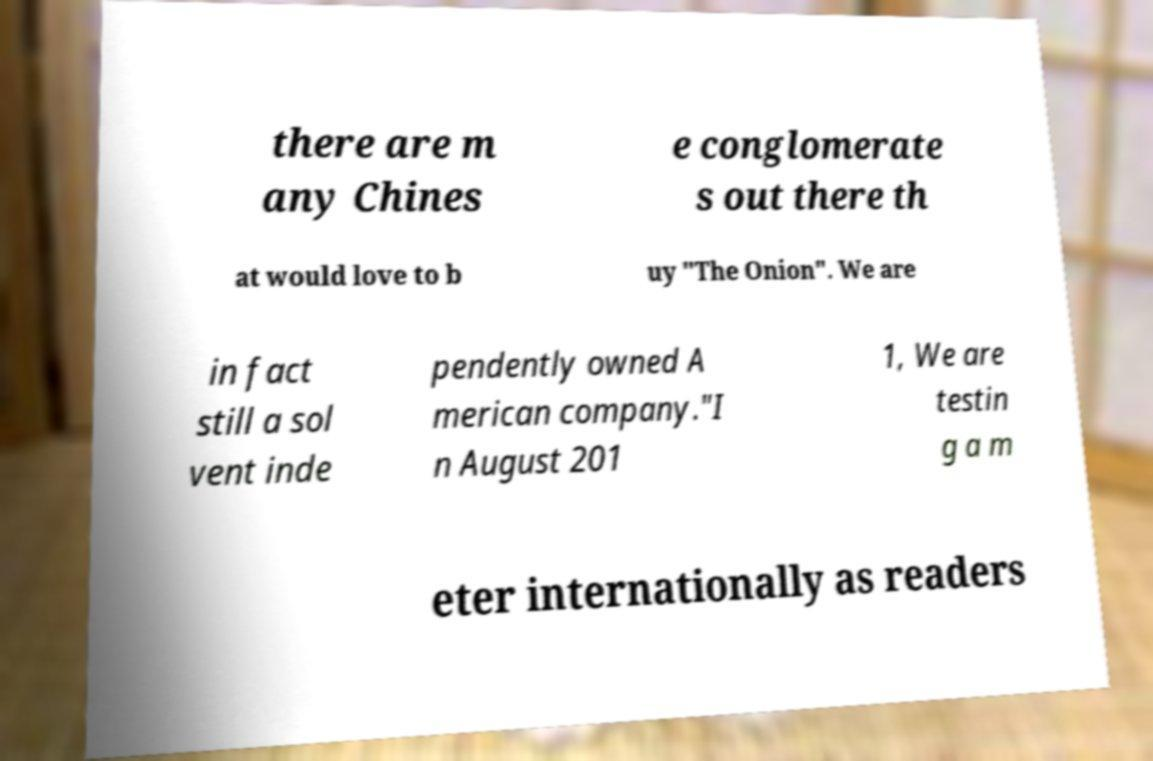There's text embedded in this image that I need extracted. Can you transcribe it verbatim? there are m any Chines e conglomerate s out there th at would love to b uy "The Onion". We are in fact still a sol vent inde pendently owned A merican company."I n August 201 1, We are testin g a m eter internationally as readers 